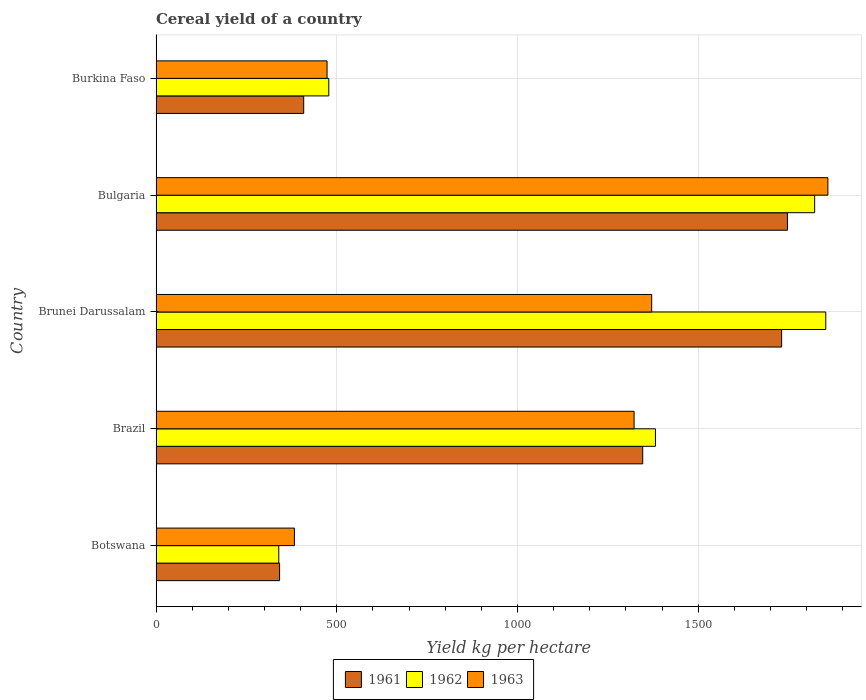How many groups of bars are there?
Offer a very short reply. 5. Are the number of bars per tick equal to the number of legend labels?
Keep it short and to the point. Yes. Are the number of bars on each tick of the Y-axis equal?
Offer a very short reply. Yes. How many bars are there on the 1st tick from the bottom?
Provide a succinct answer. 3. In how many cases, is the number of bars for a given country not equal to the number of legend labels?
Your response must be concise. 0. What is the total cereal yield in 1961 in Botswana?
Your answer should be very brief. 341.81. Across all countries, what is the maximum total cereal yield in 1962?
Provide a succinct answer. 1852.7. Across all countries, what is the minimum total cereal yield in 1962?
Your answer should be compact. 339.58. In which country was the total cereal yield in 1963 minimum?
Offer a very short reply. Botswana. What is the total total cereal yield in 1963 in the graph?
Offer a very short reply. 5408.09. What is the difference between the total cereal yield in 1961 in Brunei Darussalam and that in Bulgaria?
Provide a succinct answer. -16.03. What is the difference between the total cereal yield in 1962 in Brunei Darussalam and the total cereal yield in 1963 in Bulgaria?
Provide a short and direct response. -5.87. What is the average total cereal yield in 1963 per country?
Provide a succinct answer. 1081.62. What is the difference between the total cereal yield in 1962 and total cereal yield in 1963 in Burkina Faso?
Offer a very short reply. 4.77. What is the ratio of the total cereal yield in 1962 in Botswana to that in Burkina Faso?
Your answer should be very brief. 0.71. Is the total cereal yield in 1963 in Bulgaria less than that in Burkina Faso?
Provide a succinct answer. No. What is the difference between the highest and the second highest total cereal yield in 1963?
Your answer should be compact. 487.42. What is the difference between the highest and the lowest total cereal yield in 1963?
Ensure brevity in your answer.  1475.78. Is the sum of the total cereal yield in 1963 in Botswana and Burkina Faso greater than the maximum total cereal yield in 1962 across all countries?
Ensure brevity in your answer.  No. What does the 1st bar from the bottom in Brunei Darussalam represents?
Your response must be concise. 1961. Are all the bars in the graph horizontal?
Provide a succinct answer. Yes. How many countries are there in the graph?
Give a very brief answer. 5. Are the values on the major ticks of X-axis written in scientific E-notation?
Give a very brief answer. No. Where does the legend appear in the graph?
Offer a very short reply. Bottom center. What is the title of the graph?
Make the answer very short. Cereal yield of a country. What is the label or title of the X-axis?
Keep it short and to the point. Yield kg per hectare. What is the label or title of the Y-axis?
Your answer should be very brief. Country. What is the Yield kg per hectare in 1961 in Botswana?
Make the answer very short. 341.81. What is the Yield kg per hectare of 1962 in Botswana?
Provide a succinct answer. 339.58. What is the Yield kg per hectare in 1963 in Botswana?
Make the answer very short. 382.79. What is the Yield kg per hectare in 1961 in Brazil?
Offer a very short reply. 1346.3. What is the Yield kg per hectare of 1962 in Brazil?
Keep it short and to the point. 1381.52. What is the Yield kg per hectare in 1963 in Brazil?
Your answer should be very brief. 1322.44. What is the Yield kg per hectare of 1961 in Brunei Darussalam?
Your answer should be compact. 1730.61. What is the Yield kg per hectare of 1962 in Brunei Darussalam?
Give a very brief answer. 1852.7. What is the Yield kg per hectare of 1963 in Brunei Darussalam?
Your response must be concise. 1371.14. What is the Yield kg per hectare of 1961 in Bulgaria?
Give a very brief answer. 1746.63. What is the Yield kg per hectare of 1962 in Bulgaria?
Your answer should be compact. 1821.96. What is the Yield kg per hectare of 1963 in Bulgaria?
Your response must be concise. 1858.57. What is the Yield kg per hectare in 1961 in Burkina Faso?
Make the answer very short. 408.51. What is the Yield kg per hectare of 1962 in Burkina Faso?
Give a very brief answer. 477.91. What is the Yield kg per hectare in 1963 in Burkina Faso?
Give a very brief answer. 473.15. Across all countries, what is the maximum Yield kg per hectare in 1961?
Provide a short and direct response. 1746.63. Across all countries, what is the maximum Yield kg per hectare of 1962?
Offer a very short reply. 1852.7. Across all countries, what is the maximum Yield kg per hectare of 1963?
Offer a very short reply. 1858.57. Across all countries, what is the minimum Yield kg per hectare in 1961?
Keep it short and to the point. 341.81. Across all countries, what is the minimum Yield kg per hectare in 1962?
Offer a terse response. 339.58. Across all countries, what is the minimum Yield kg per hectare of 1963?
Your answer should be very brief. 382.79. What is the total Yield kg per hectare of 1961 in the graph?
Make the answer very short. 5573.85. What is the total Yield kg per hectare in 1962 in the graph?
Ensure brevity in your answer.  5873.67. What is the total Yield kg per hectare in 1963 in the graph?
Your response must be concise. 5408.09. What is the difference between the Yield kg per hectare in 1961 in Botswana and that in Brazil?
Your answer should be compact. -1004.49. What is the difference between the Yield kg per hectare of 1962 in Botswana and that in Brazil?
Offer a terse response. -1041.95. What is the difference between the Yield kg per hectare in 1963 in Botswana and that in Brazil?
Make the answer very short. -939.65. What is the difference between the Yield kg per hectare in 1961 in Botswana and that in Brunei Darussalam?
Your answer should be compact. -1388.8. What is the difference between the Yield kg per hectare in 1962 in Botswana and that in Brunei Darussalam?
Ensure brevity in your answer.  -1513.13. What is the difference between the Yield kg per hectare in 1963 in Botswana and that in Brunei Darussalam?
Provide a short and direct response. -988.36. What is the difference between the Yield kg per hectare in 1961 in Botswana and that in Bulgaria?
Provide a short and direct response. -1404.83. What is the difference between the Yield kg per hectare in 1962 in Botswana and that in Bulgaria?
Give a very brief answer. -1482.38. What is the difference between the Yield kg per hectare of 1963 in Botswana and that in Bulgaria?
Keep it short and to the point. -1475.78. What is the difference between the Yield kg per hectare of 1961 in Botswana and that in Burkina Faso?
Your answer should be very brief. -66.7. What is the difference between the Yield kg per hectare of 1962 in Botswana and that in Burkina Faso?
Give a very brief answer. -138.34. What is the difference between the Yield kg per hectare in 1963 in Botswana and that in Burkina Faso?
Offer a terse response. -90.36. What is the difference between the Yield kg per hectare of 1961 in Brazil and that in Brunei Darussalam?
Offer a very short reply. -384.31. What is the difference between the Yield kg per hectare in 1962 in Brazil and that in Brunei Darussalam?
Your answer should be very brief. -471.18. What is the difference between the Yield kg per hectare in 1963 in Brazil and that in Brunei Darussalam?
Provide a succinct answer. -48.7. What is the difference between the Yield kg per hectare in 1961 in Brazil and that in Bulgaria?
Provide a succinct answer. -400.33. What is the difference between the Yield kg per hectare in 1962 in Brazil and that in Bulgaria?
Your answer should be compact. -440.43. What is the difference between the Yield kg per hectare of 1963 in Brazil and that in Bulgaria?
Make the answer very short. -536.12. What is the difference between the Yield kg per hectare of 1961 in Brazil and that in Burkina Faso?
Make the answer very short. 937.79. What is the difference between the Yield kg per hectare of 1962 in Brazil and that in Burkina Faso?
Make the answer very short. 903.61. What is the difference between the Yield kg per hectare in 1963 in Brazil and that in Burkina Faso?
Your answer should be very brief. 849.3. What is the difference between the Yield kg per hectare in 1961 in Brunei Darussalam and that in Bulgaria?
Give a very brief answer. -16.03. What is the difference between the Yield kg per hectare in 1962 in Brunei Darussalam and that in Bulgaria?
Provide a succinct answer. 30.75. What is the difference between the Yield kg per hectare in 1963 in Brunei Darussalam and that in Bulgaria?
Offer a terse response. -487.42. What is the difference between the Yield kg per hectare in 1961 in Brunei Darussalam and that in Burkina Faso?
Provide a short and direct response. 1322.1. What is the difference between the Yield kg per hectare of 1962 in Brunei Darussalam and that in Burkina Faso?
Offer a terse response. 1374.79. What is the difference between the Yield kg per hectare of 1963 in Brunei Darussalam and that in Burkina Faso?
Make the answer very short. 898. What is the difference between the Yield kg per hectare in 1961 in Bulgaria and that in Burkina Faso?
Provide a succinct answer. 1338.12. What is the difference between the Yield kg per hectare in 1962 in Bulgaria and that in Burkina Faso?
Your answer should be very brief. 1344.04. What is the difference between the Yield kg per hectare of 1963 in Bulgaria and that in Burkina Faso?
Provide a succinct answer. 1385.42. What is the difference between the Yield kg per hectare in 1961 in Botswana and the Yield kg per hectare in 1962 in Brazil?
Your answer should be compact. -1039.71. What is the difference between the Yield kg per hectare in 1961 in Botswana and the Yield kg per hectare in 1963 in Brazil?
Make the answer very short. -980.64. What is the difference between the Yield kg per hectare in 1962 in Botswana and the Yield kg per hectare in 1963 in Brazil?
Provide a succinct answer. -982.87. What is the difference between the Yield kg per hectare in 1961 in Botswana and the Yield kg per hectare in 1962 in Brunei Darussalam?
Give a very brief answer. -1510.89. What is the difference between the Yield kg per hectare of 1961 in Botswana and the Yield kg per hectare of 1963 in Brunei Darussalam?
Keep it short and to the point. -1029.34. What is the difference between the Yield kg per hectare of 1962 in Botswana and the Yield kg per hectare of 1963 in Brunei Darussalam?
Offer a very short reply. -1031.57. What is the difference between the Yield kg per hectare in 1961 in Botswana and the Yield kg per hectare in 1962 in Bulgaria?
Offer a very short reply. -1480.15. What is the difference between the Yield kg per hectare of 1961 in Botswana and the Yield kg per hectare of 1963 in Bulgaria?
Your response must be concise. -1516.76. What is the difference between the Yield kg per hectare of 1962 in Botswana and the Yield kg per hectare of 1963 in Bulgaria?
Ensure brevity in your answer.  -1518.99. What is the difference between the Yield kg per hectare of 1961 in Botswana and the Yield kg per hectare of 1962 in Burkina Faso?
Ensure brevity in your answer.  -136.11. What is the difference between the Yield kg per hectare of 1961 in Botswana and the Yield kg per hectare of 1963 in Burkina Faso?
Offer a terse response. -131.34. What is the difference between the Yield kg per hectare in 1962 in Botswana and the Yield kg per hectare in 1963 in Burkina Faso?
Ensure brevity in your answer.  -133.57. What is the difference between the Yield kg per hectare of 1961 in Brazil and the Yield kg per hectare of 1962 in Brunei Darussalam?
Offer a very short reply. -506.4. What is the difference between the Yield kg per hectare of 1961 in Brazil and the Yield kg per hectare of 1963 in Brunei Darussalam?
Keep it short and to the point. -24.84. What is the difference between the Yield kg per hectare in 1962 in Brazil and the Yield kg per hectare in 1963 in Brunei Darussalam?
Offer a terse response. 10.38. What is the difference between the Yield kg per hectare of 1961 in Brazil and the Yield kg per hectare of 1962 in Bulgaria?
Your answer should be compact. -475.65. What is the difference between the Yield kg per hectare of 1961 in Brazil and the Yield kg per hectare of 1963 in Bulgaria?
Offer a terse response. -512.27. What is the difference between the Yield kg per hectare of 1962 in Brazil and the Yield kg per hectare of 1963 in Bulgaria?
Your response must be concise. -477.05. What is the difference between the Yield kg per hectare in 1961 in Brazil and the Yield kg per hectare in 1962 in Burkina Faso?
Provide a succinct answer. 868.39. What is the difference between the Yield kg per hectare in 1961 in Brazil and the Yield kg per hectare in 1963 in Burkina Faso?
Make the answer very short. 873.15. What is the difference between the Yield kg per hectare of 1962 in Brazil and the Yield kg per hectare of 1963 in Burkina Faso?
Provide a short and direct response. 908.38. What is the difference between the Yield kg per hectare in 1961 in Brunei Darussalam and the Yield kg per hectare in 1962 in Bulgaria?
Provide a succinct answer. -91.35. What is the difference between the Yield kg per hectare of 1961 in Brunei Darussalam and the Yield kg per hectare of 1963 in Bulgaria?
Offer a very short reply. -127.96. What is the difference between the Yield kg per hectare of 1962 in Brunei Darussalam and the Yield kg per hectare of 1963 in Bulgaria?
Your answer should be compact. -5.87. What is the difference between the Yield kg per hectare of 1961 in Brunei Darussalam and the Yield kg per hectare of 1962 in Burkina Faso?
Your answer should be compact. 1252.69. What is the difference between the Yield kg per hectare of 1961 in Brunei Darussalam and the Yield kg per hectare of 1963 in Burkina Faso?
Your answer should be compact. 1257.46. What is the difference between the Yield kg per hectare of 1962 in Brunei Darussalam and the Yield kg per hectare of 1963 in Burkina Faso?
Your response must be concise. 1379.56. What is the difference between the Yield kg per hectare of 1961 in Bulgaria and the Yield kg per hectare of 1962 in Burkina Faso?
Provide a short and direct response. 1268.72. What is the difference between the Yield kg per hectare in 1961 in Bulgaria and the Yield kg per hectare in 1963 in Burkina Faso?
Your response must be concise. 1273.49. What is the difference between the Yield kg per hectare of 1962 in Bulgaria and the Yield kg per hectare of 1963 in Burkina Faso?
Your answer should be compact. 1348.81. What is the average Yield kg per hectare of 1961 per country?
Ensure brevity in your answer.  1114.77. What is the average Yield kg per hectare in 1962 per country?
Ensure brevity in your answer.  1174.73. What is the average Yield kg per hectare in 1963 per country?
Provide a succinct answer. 1081.62. What is the difference between the Yield kg per hectare in 1961 and Yield kg per hectare in 1962 in Botswana?
Your response must be concise. 2.23. What is the difference between the Yield kg per hectare of 1961 and Yield kg per hectare of 1963 in Botswana?
Give a very brief answer. -40.98. What is the difference between the Yield kg per hectare of 1962 and Yield kg per hectare of 1963 in Botswana?
Provide a short and direct response. -43.21. What is the difference between the Yield kg per hectare in 1961 and Yield kg per hectare in 1962 in Brazil?
Your answer should be very brief. -35.22. What is the difference between the Yield kg per hectare of 1961 and Yield kg per hectare of 1963 in Brazil?
Offer a very short reply. 23.86. What is the difference between the Yield kg per hectare of 1962 and Yield kg per hectare of 1963 in Brazil?
Give a very brief answer. 59.08. What is the difference between the Yield kg per hectare of 1961 and Yield kg per hectare of 1962 in Brunei Darussalam?
Provide a succinct answer. -122.1. What is the difference between the Yield kg per hectare of 1961 and Yield kg per hectare of 1963 in Brunei Darussalam?
Provide a short and direct response. 359.46. What is the difference between the Yield kg per hectare of 1962 and Yield kg per hectare of 1963 in Brunei Darussalam?
Ensure brevity in your answer.  481.56. What is the difference between the Yield kg per hectare of 1961 and Yield kg per hectare of 1962 in Bulgaria?
Ensure brevity in your answer.  -75.32. What is the difference between the Yield kg per hectare of 1961 and Yield kg per hectare of 1963 in Bulgaria?
Make the answer very short. -111.93. What is the difference between the Yield kg per hectare in 1962 and Yield kg per hectare in 1963 in Bulgaria?
Ensure brevity in your answer.  -36.61. What is the difference between the Yield kg per hectare in 1961 and Yield kg per hectare in 1962 in Burkina Faso?
Offer a very short reply. -69.41. What is the difference between the Yield kg per hectare in 1961 and Yield kg per hectare in 1963 in Burkina Faso?
Provide a short and direct response. -64.64. What is the difference between the Yield kg per hectare of 1962 and Yield kg per hectare of 1963 in Burkina Faso?
Provide a succinct answer. 4.77. What is the ratio of the Yield kg per hectare of 1961 in Botswana to that in Brazil?
Your response must be concise. 0.25. What is the ratio of the Yield kg per hectare of 1962 in Botswana to that in Brazil?
Keep it short and to the point. 0.25. What is the ratio of the Yield kg per hectare of 1963 in Botswana to that in Brazil?
Ensure brevity in your answer.  0.29. What is the ratio of the Yield kg per hectare in 1961 in Botswana to that in Brunei Darussalam?
Your answer should be very brief. 0.2. What is the ratio of the Yield kg per hectare in 1962 in Botswana to that in Brunei Darussalam?
Your answer should be very brief. 0.18. What is the ratio of the Yield kg per hectare of 1963 in Botswana to that in Brunei Darussalam?
Your answer should be very brief. 0.28. What is the ratio of the Yield kg per hectare of 1961 in Botswana to that in Bulgaria?
Give a very brief answer. 0.2. What is the ratio of the Yield kg per hectare of 1962 in Botswana to that in Bulgaria?
Make the answer very short. 0.19. What is the ratio of the Yield kg per hectare in 1963 in Botswana to that in Bulgaria?
Offer a very short reply. 0.21. What is the ratio of the Yield kg per hectare in 1961 in Botswana to that in Burkina Faso?
Provide a short and direct response. 0.84. What is the ratio of the Yield kg per hectare in 1962 in Botswana to that in Burkina Faso?
Offer a very short reply. 0.71. What is the ratio of the Yield kg per hectare of 1963 in Botswana to that in Burkina Faso?
Provide a succinct answer. 0.81. What is the ratio of the Yield kg per hectare in 1961 in Brazil to that in Brunei Darussalam?
Offer a very short reply. 0.78. What is the ratio of the Yield kg per hectare of 1962 in Brazil to that in Brunei Darussalam?
Offer a very short reply. 0.75. What is the ratio of the Yield kg per hectare of 1963 in Brazil to that in Brunei Darussalam?
Offer a terse response. 0.96. What is the ratio of the Yield kg per hectare of 1961 in Brazil to that in Bulgaria?
Make the answer very short. 0.77. What is the ratio of the Yield kg per hectare of 1962 in Brazil to that in Bulgaria?
Your answer should be very brief. 0.76. What is the ratio of the Yield kg per hectare of 1963 in Brazil to that in Bulgaria?
Your answer should be compact. 0.71. What is the ratio of the Yield kg per hectare of 1961 in Brazil to that in Burkina Faso?
Make the answer very short. 3.3. What is the ratio of the Yield kg per hectare in 1962 in Brazil to that in Burkina Faso?
Provide a succinct answer. 2.89. What is the ratio of the Yield kg per hectare in 1963 in Brazil to that in Burkina Faso?
Your response must be concise. 2.79. What is the ratio of the Yield kg per hectare of 1961 in Brunei Darussalam to that in Bulgaria?
Make the answer very short. 0.99. What is the ratio of the Yield kg per hectare in 1962 in Brunei Darussalam to that in Bulgaria?
Keep it short and to the point. 1.02. What is the ratio of the Yield kg per hectare in 1963 in Brunei Darussalam to that in Bulgaria?
Keep it short and to the point. 0.74. What is the ratio of the Yield kg per hectare in 1961 in Brunei Darussalam to that in Burkina Faso?
Offer a terse response. 4.24. What is the ratio of the Yield kg per hectare in 1962 in Brunei Darussalam to that in Burkina Faso?
Your response must be concise. 3.88. What is the ratio of the Yield kg per hectare in 1963 in Brunei Darussalam to that in Burkina Faso?
Make the answer very short. 2.9. What is the ratio of the Yield kg per hectare of 1961 in Bulgaria to that in Burkina Faso?
Your response must be concise. 4.28. What is the ratio of the Yield kg per hectare in 1962 in Bulgaria to that in Burkina Faso?
Offer a very short reply. 3.81. What is the ratio of the Yield kg per hectare of 1963 in Bulgaria to that in Burkina Faso?
Offer a terse response. 3.93. What is the difference between the highest and the second highest Yield kg per hectare in 1961?
Your answer should be compact. 16.03. What is the difference between the highest and the second highest Yield kg per hectare of 1962?
Make the answer very short. 30.75. What is the difference between the highest and the second highest Yield kg per hectare in 1963?
Keep it short and to the point. 487.42. What is the difference between the highest and the lowest Yield kg per hectare of 1961?
Provide a short and direct response. 1404.83. What is the difference between the highest and the lowest Yield kg per hectare of 1962?
Make the answer very short. 1513.13. What is the difference between the highest and the lowest Yield kg per hectare of 1963?
Give a very brief answer. 1475.78. 